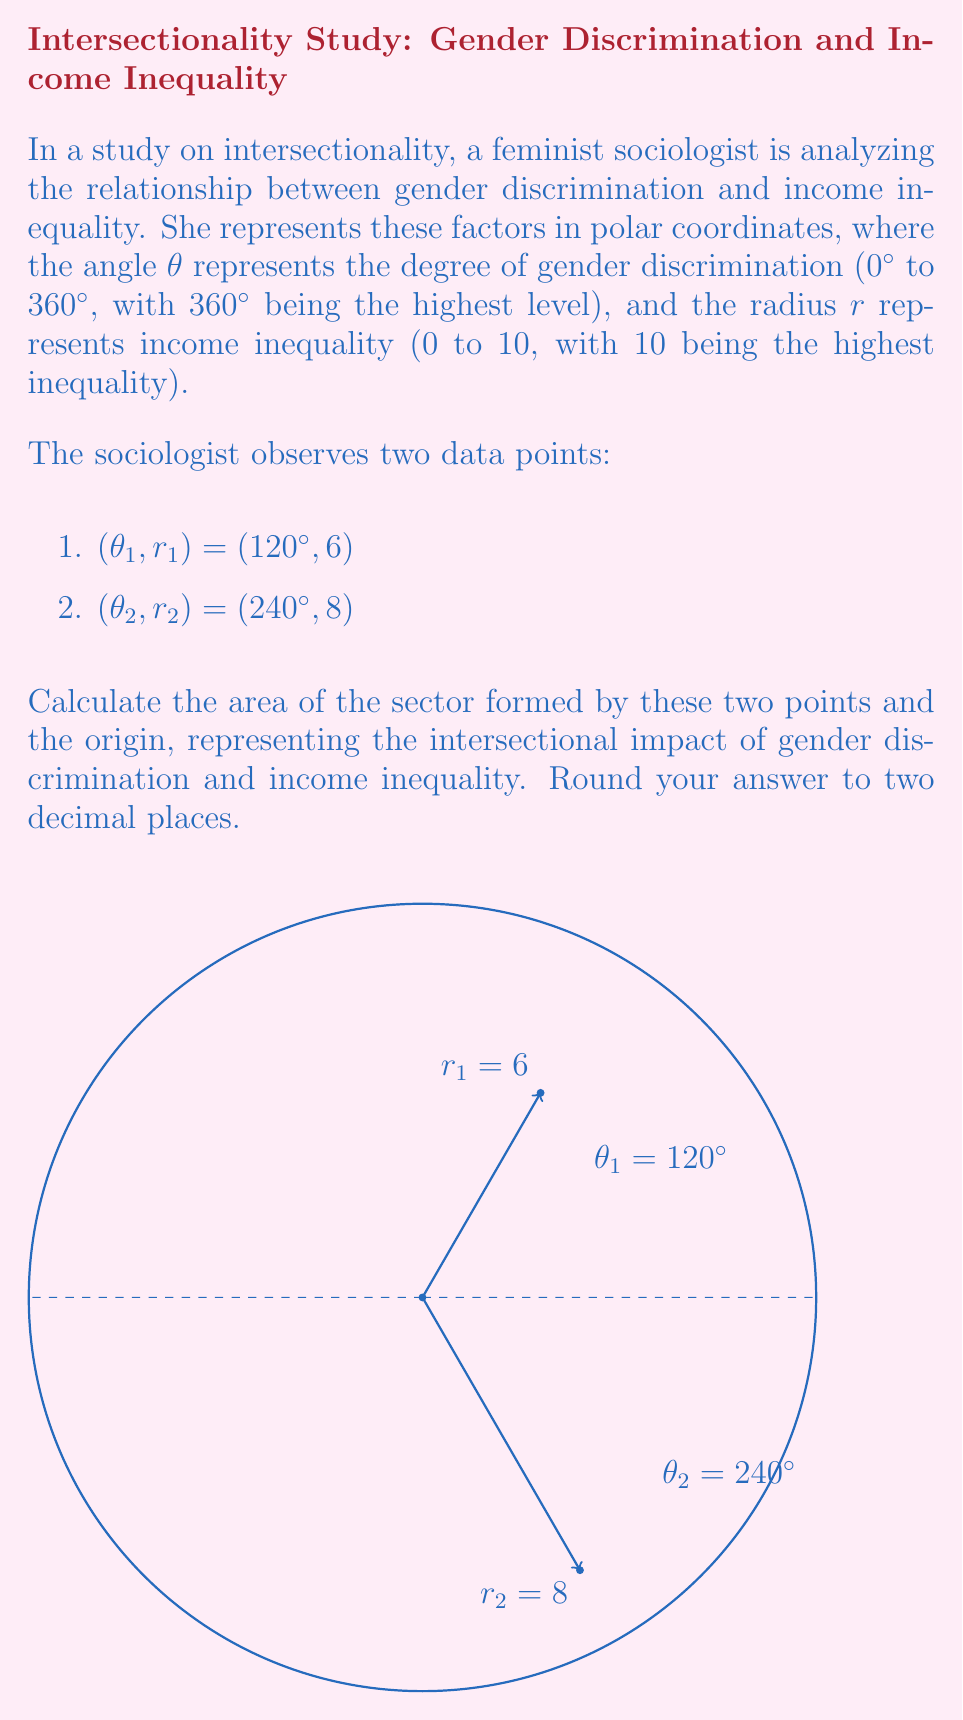Provide a solution to this math problem. To solve this problem, we'll follow these steps:

1) The area of a sector in polar coordinates is given by the formula:

   $$A = \frac{1}{2} \int_{\theta_1}^{\theta_2} r^2 d\theta$$

2) In this case, we don't have a continuous function for r, but two discrete points. We can approximate the area by using the average of the two radii:

   $$r_{avg} = \frac{r_1 + r_2}{2} = \frac{6 + 8}{2} = 7$$

3) Now we can use the formula for the area of a sector with a constant radius:

   $$A = \frac{1}{2} r^2 (\theta_2 - \theta_1)$$

   Where θ is in radians.

4) Convert the angle difference from degrees to radians:

   $$240° - 120° = 120° = \frac{2\pi}{3} \text{ radians}$$

5) Substitute the values into the formula:

   $$A = \frac{1}{2} (7^2) (\frac{2\pi}{3})$$

6) Calculate:

   $$A = \frac{1}{2} (49) (\frac{2\pi}{3}) = \frac{49\pi}{3} \approx 51.31$$

7) Round to two decimal places: 51.31

This area represents the intersectional impact of gender discrimination and income inequality in the study.
Answer: 51.31 